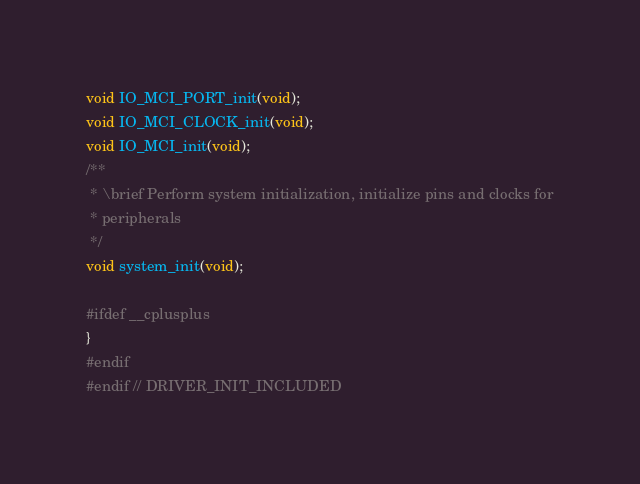<code> <loc_0><loc_0><loc_500><loc_500><_C_>void IO_MCI_PORT_init(void);
void IO_MCI_CLOCK_init(void);
void IO_MCI_init(void);
/**
 * \brief Perform system initialization, initialize pins and clocks for
 * peripherals
 */
void system_init(void);

#ifdef __cplusplus
}
#endif
#endif // DRIVER_INIT_INCLUDED
</code> 